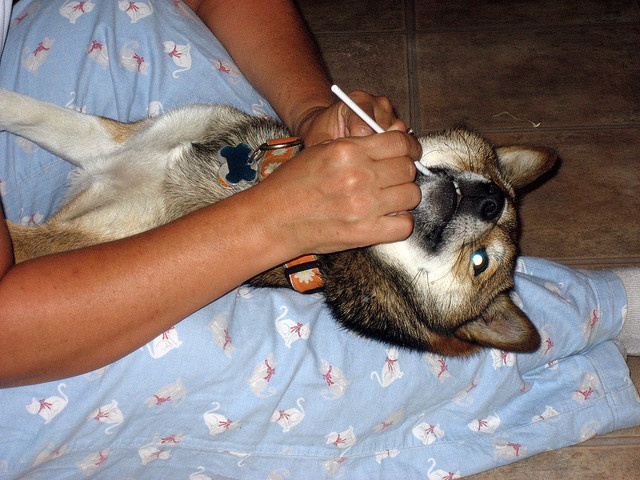Describe the objects in this image and their specific colors. I can see people in lavender, darkgray, lightblue, and salmon tones, dog in lavender, black, darkgray, and gray tones, and toothbrush in lavender, white, darkgray, maroon, and gray tones in this image. 